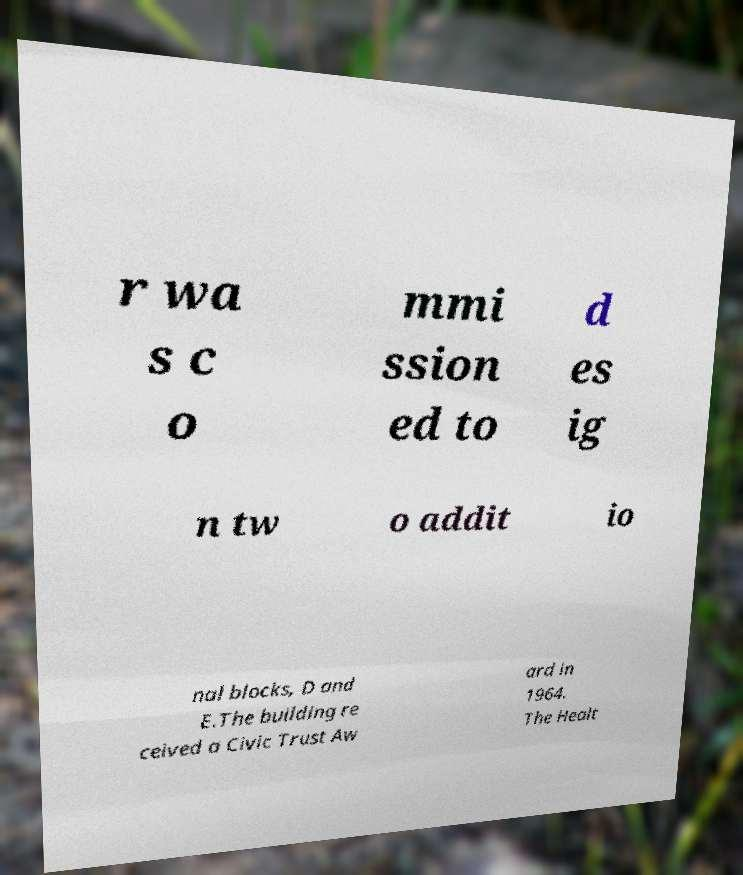What messages or text are displayed in this image? I need them in a readable, typed format. r wa s c o mmi ssion ed to d es ig n tw o addit io nal blocks, D and E.The building re ceived a Civic Trust Aw ard in 1964. The Healt 